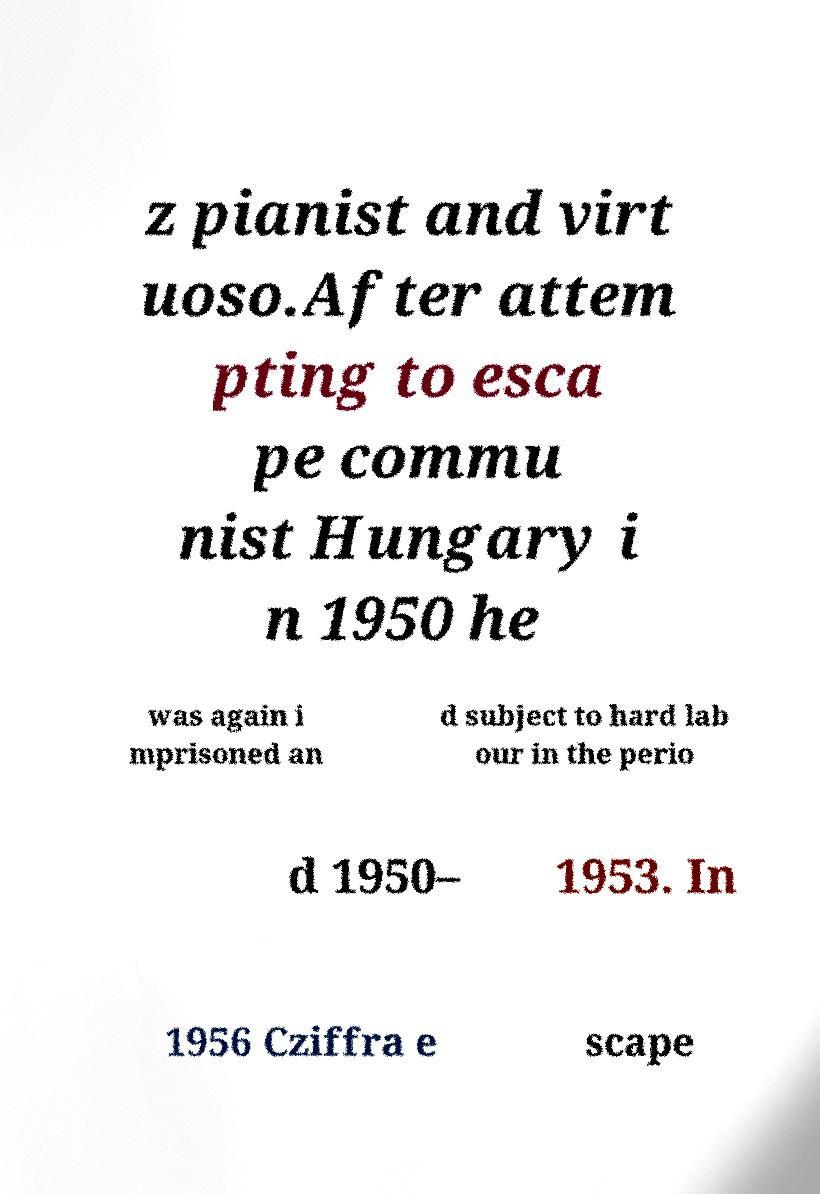Please identify and transcribe the text found in this image. z pianist and virt uoso.After attem pting to esca pe commu nist Hungary i n 1950 he was again i mprisoned an d subject to hard lab our in the perio d 1950– 1953. In 1956 Cziffra e scape 